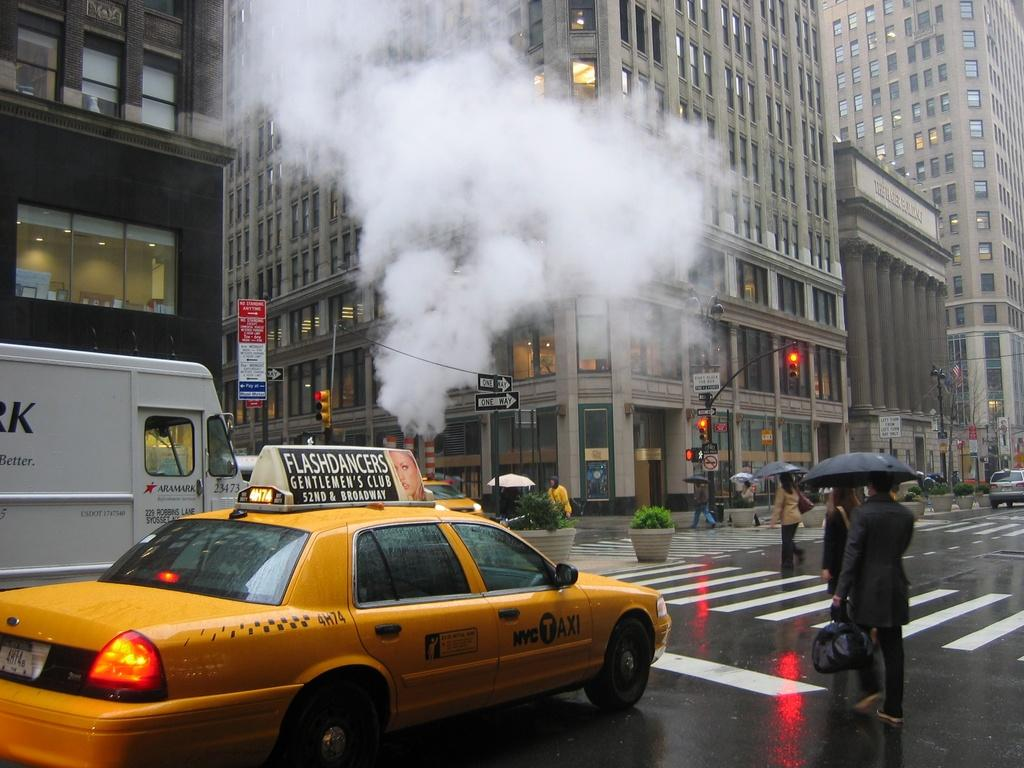<image>
Summarize the visual content of the image. A NYC Taxi with an ad for Flashdancers Gentlemen's Club is stopped at a crosswalk. 